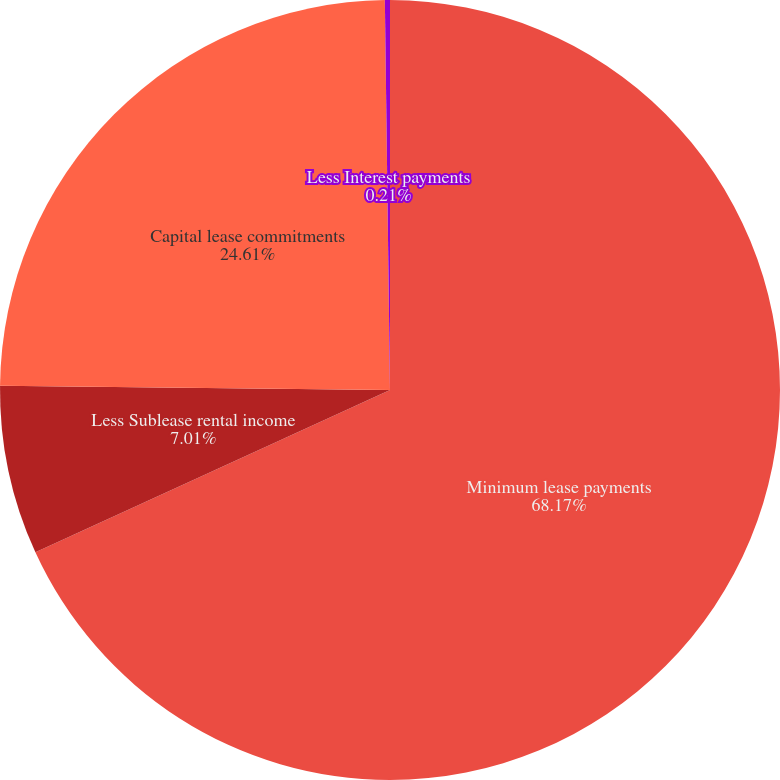Convert chart. <chart><loc_0><loc_0><loc_500><loc_500><pie_chart><fcel>Minimum lease payments<fcel>Less Sublease rental income<fcel>Capital lease commitments<fcel>Less Interest payments<nl><fcel>68.16%<fcel>7.01%<fcel>24.61%<fcel>0.21%<nl></chart> 